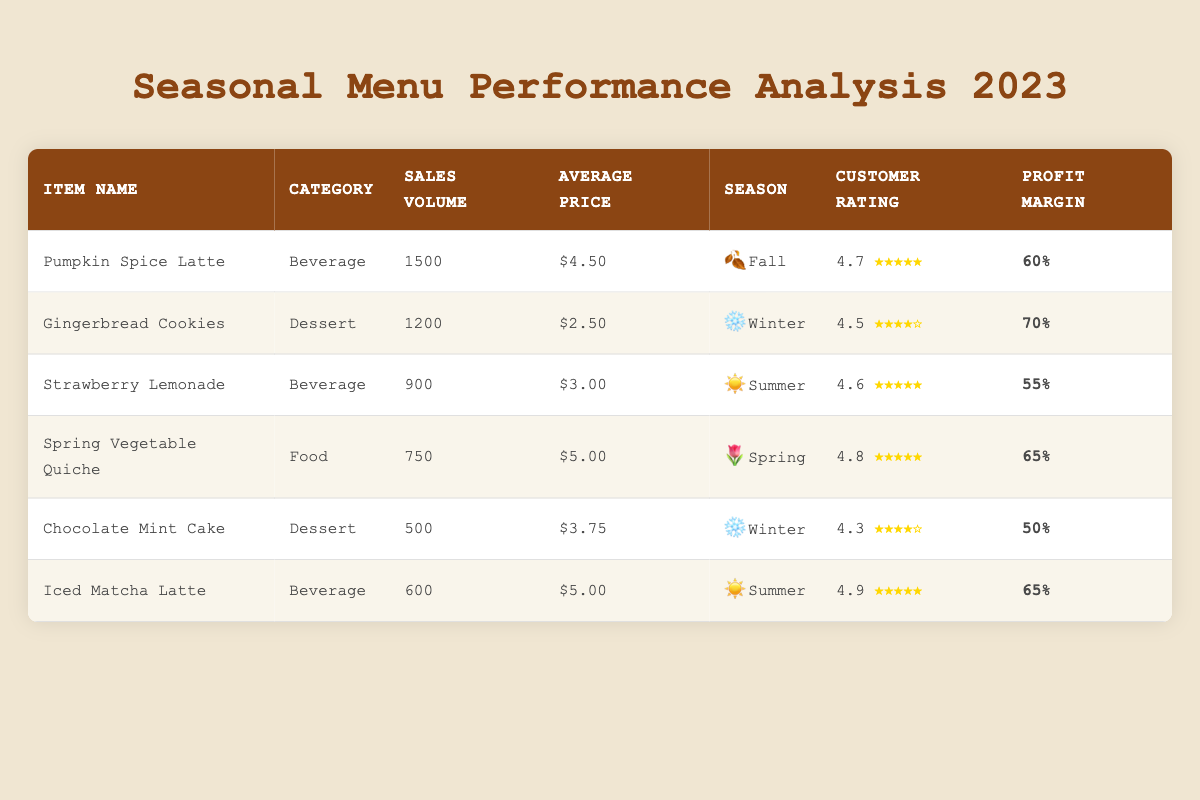What is the sales volume of the Pumpkin Spice Latte? The sales volume for the Pumpkin Spice Latte is directly listed in the table under the "Sales Volume" column, which shows 1500.
Answer: 1500 Which seasonal item has the highest customer rating? By examining the "Customer Rating" column, the Spring Vegetable Quiche has a rating of 4.8, which is the highest compared to other items listed.
Answer: Spring Vegetable Quiche What is the profit margin for Gingerbread Cookies compared to Chocolate Mint Cake? The profit margin for Gingerbread Cookies is 70%, while for Chocolate Mint Cake it is 50%. So, Gingerbread Cookies has a higher profit margin by 20%.
Answer: 20% What is the average sales volume of all items listed in the table? The sales volumes are 1500, 1200, 900, 750, 500, and 600. Summing these volumes gives 4500, and dividing by the number of items (6) yields an average of 750.
Answer: 750 Is the average price of Dessert items higher than that of Beverage items? The average price for Dessert items (Gingerbread Cookies at 2.50 and Chocolate Mint Cake at 3.75) is (2.50 + 3.75) / 2 = 3.125. For Beverages (Pumpkin Spice Latte at 4.50, Strawberry Lemonade at 3.00, and Iced Matcha Latte at 5.00) is (4.50 + 3.00 + 5.00) / 3 = 4.17, which makes the average price of Beverages higher.
Answer: No How much did the best-selling item earn in profit? The best-selling item is the Pumpkin Spice Latte with a sales volume of 1500 and an average price of 4.50. The revenue calculated is 1500 * 4.50 = 6750. Given a profit margin of 60%, the profit is 6750 * 0.60 = 4050.
Answer: 4050 